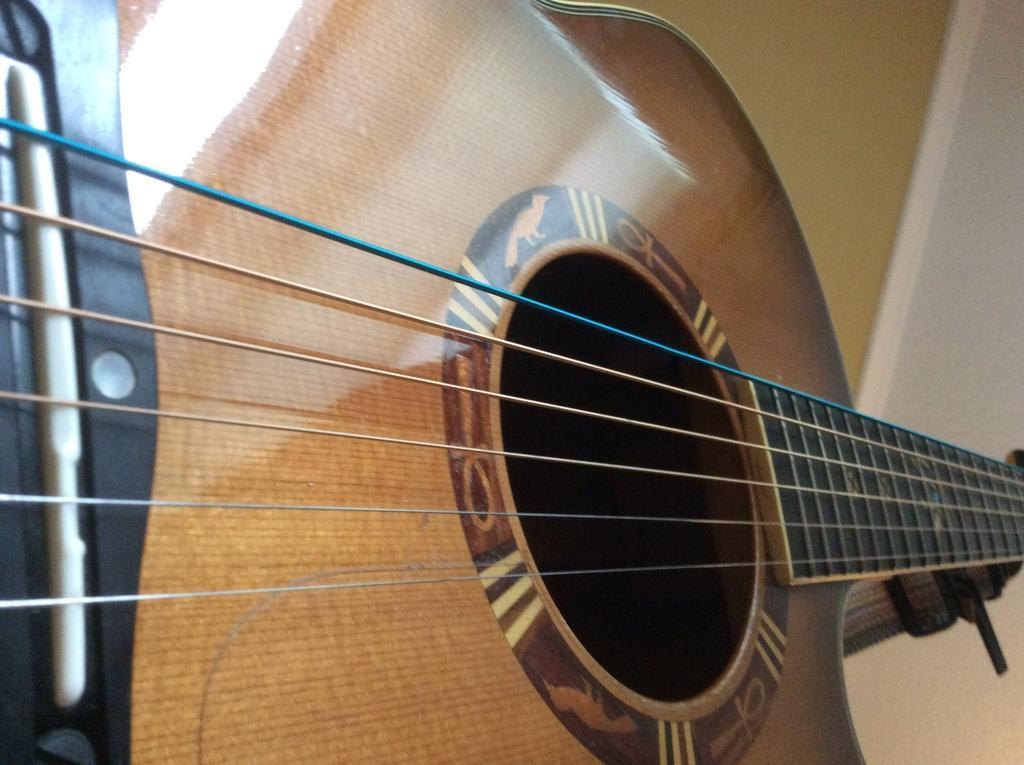Describe this image in one or two sentences. This picture is mainly highlighted with a guitar. 